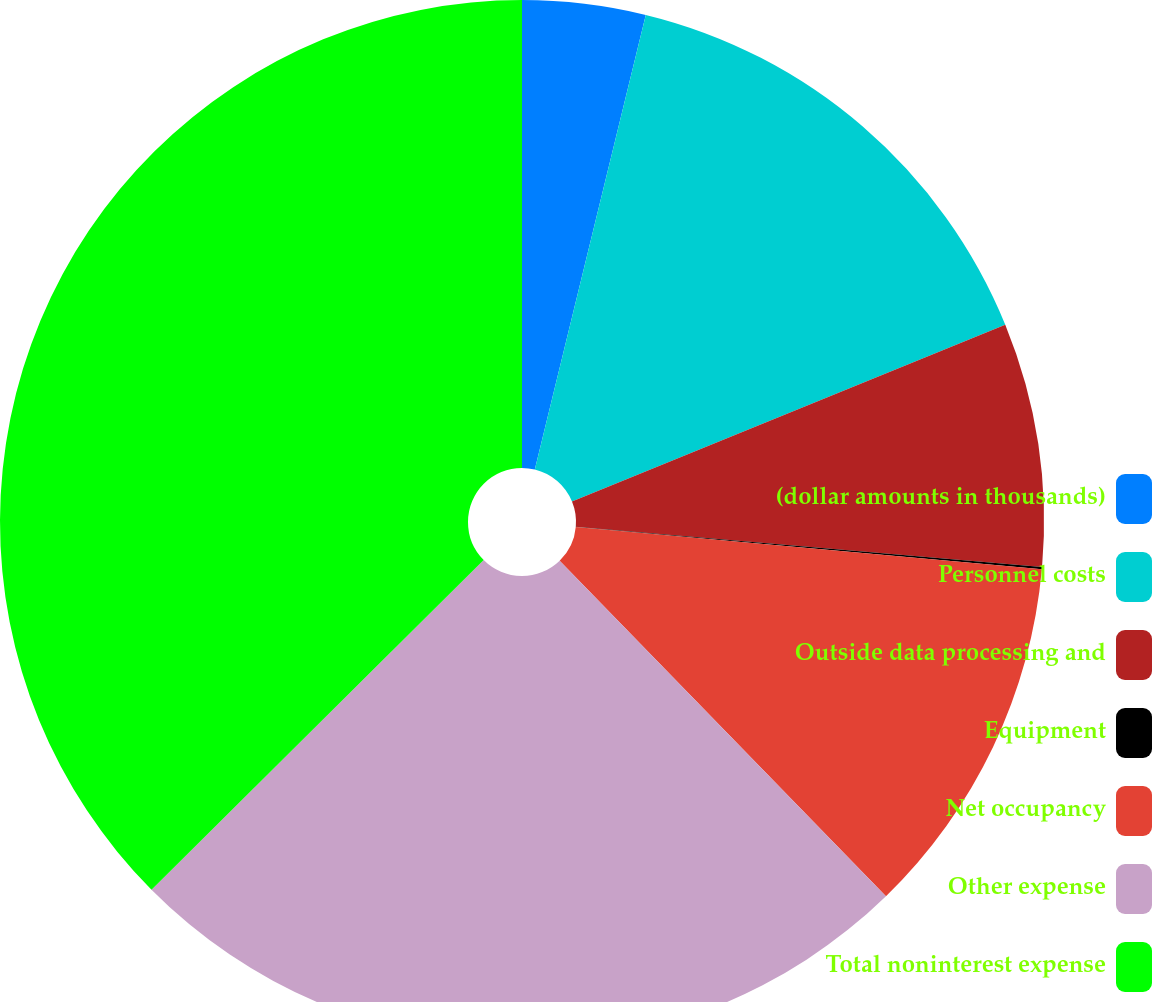Convert chart. <chart><loc_0><loc_0><loc_500><loc_500><pie_chart><fcel>(dollar amounts in thousands)<fcel>Personnel costs<fcel>Outside data processing and<fcel>Equipment<fcel>Net occupancy<fcel>Other expense<fcel>Total noninterest expense<nl><fcel>3.81%<fcel>15.02%<fcel>7.54%<fcel>0.07%<fcel>11.28%<fcel>24.84%<fcel>37.44%<nl></chart> 